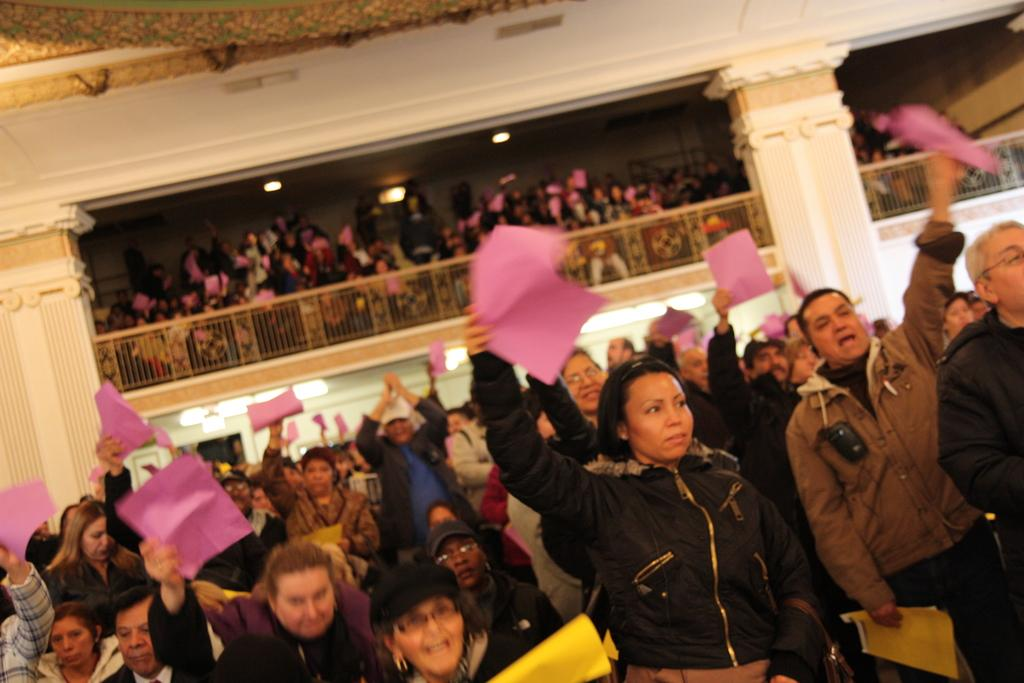What are the people in the image holding? There is a group of people holding papers in the image. What can be seen in the background of the image? There is a railing and many people in the background of the image. What is visible at the top of the image? There are lights visible at the top of the image. How many pens are visible in the image? There is no pen present in the image. What is the balance of the group of people holding papers? The balance of the group of people holding papers cannot be determined from the image, as it does not provide information about their physical positions or weights. 